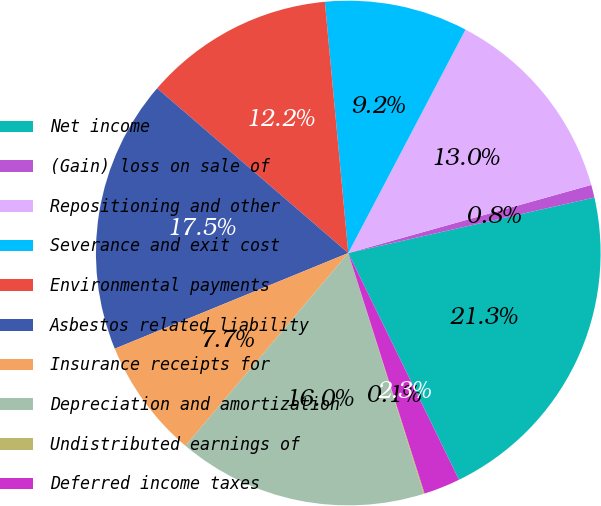Convert chart. <chart><loc_0><loc_0><loc_500><loc_500><pie_chart><fcel>Net income<fcel>(Gain) loss on sale of<fcel>Repositioning and other<fcel>Severance and exit cost<fcel>Environmental payments<fcel>Asbestos related liability<fcel>Insurance receipts for<fcel>Depreciation and amortization<fcel>Undistributed earnings of<fcel>Deferred income taxes<nl><fcel>21.3%<fcel>0.82%<fcel>12.96%<fcel>9.17%<fcel>12.2%<fcel>17.51%<fcel>7.65%<fcel>15.99%<fcel>0.06%<fcel>2.34%<nl></chart> 